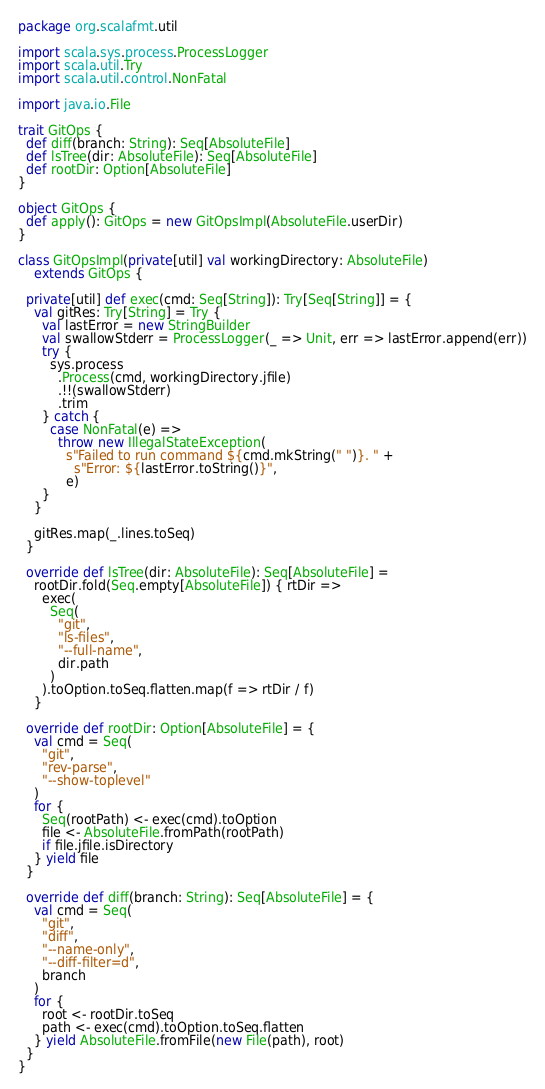Convert code to text. <code><loc_0><loc_0><loc_500><loc_500><_Scala_>package org.scalafmt.util

import scala.sys.process.ProcessLogger
import scala.util.Try
import scala.util.control.NonFatal

import java.io.File

trait GitOps {
  def diff(branch: String): Seq[AbsoluteFile]
  def lsTree(dir: AbsoluteFile): Seq[AbsoluteFile]
  def rootDir: Option[AbsoluteFile]
}

object GitOps {
  def apply(): GitOps = new GitOpsImpl(AbsoluteFile.userDir)
}

class GitOpsImpl(private[util] val workingDirectory: AbsoluteFile)
    extends GitOps {

  private[util] def exec(cmd: Seq[String]): Try[Seq[String]] = {
    val gitRes: Try[String] = Try {
      val lastError = new StringBuilder
      val swallowStderr = ProcessLogger(_ => Unit, err => lastError.append(err))
      try {
        sys.process
          .Process(cmd, workingDirectory.jfile)
          .!!(swallowStderr)
          .trim
      } catch {
        case NonFatal(e) =>
          throw new IllegalStateException(
            s"Failed to run command ${cmd.mkString(" ")}. " +
              s"Error: ${lastError.toString()}",
            e)
      }
    }

    gitRes.map(_.lines.toSeq)
  }

  override def lsTree(dir: AbsoluteFile): Seq[AbsoluteFile] =
    rootDir.fold(Seq.empty[AbsoluteFile]) { rtDir =>
      exec(
        Seq(
          "git",
          "ls-files",
          "--full-name",
          dir.path
        )
      ).toOption.toSeq.flatten.map(f => rtDir / f)
    }

  override def rootDir: Option[AbsoluteFile] = {
    val cmd = Seq(
      "git",
      "rev-parse",
      "--show-toplevel"
    )
    for {
      Seq(rootPath) <- exec(cmd).toOption
      file <- AbsoluteFile.fromPath(rootPath)
      if file.jfile.isDirectory
    } yield file
  }

  override def diff(branch: String): Seq[AbsoluteFile] = {
    val cmd = Seq(
      "git",
      "diff",
      "--name-only",
      "--diff-filter=d",
      branch
    )
    for {
      root <- rootDir.toSeq
      path <- exec(cmd).toOption.toSeq.flatten
    } yield AbsoluteFile.fromFile(new File(path), root)
  }
}
</code> 